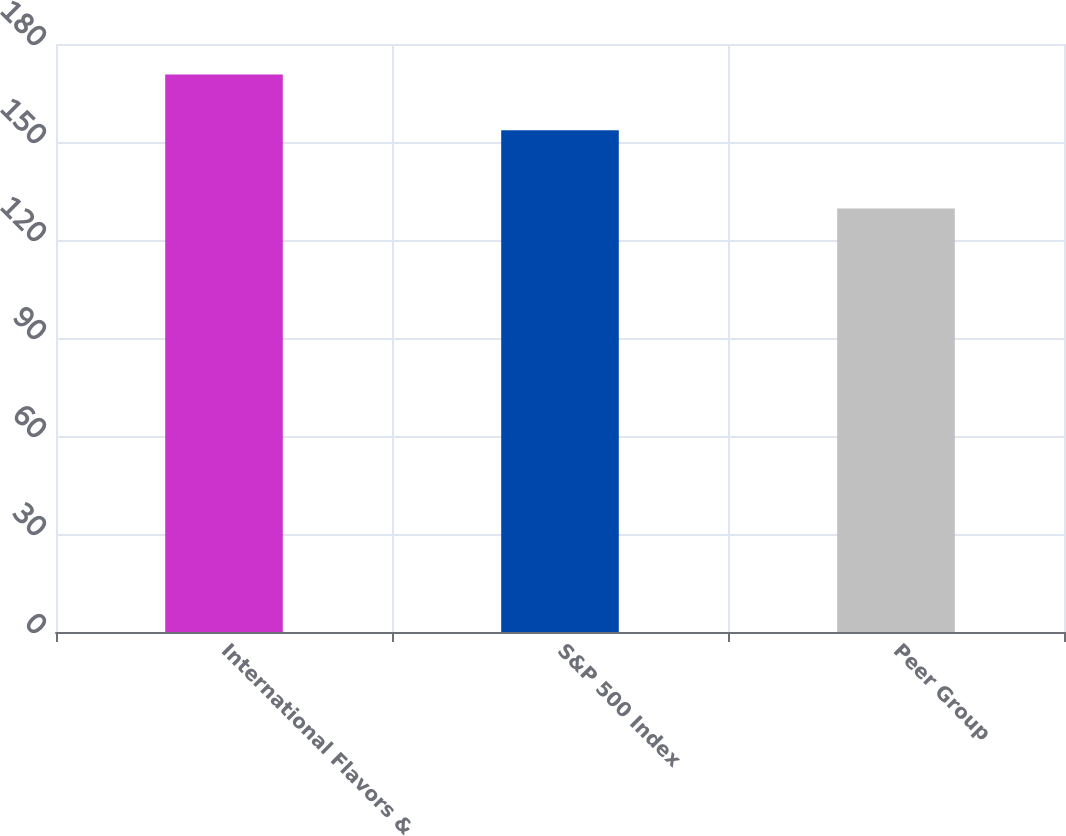Convert chart to OTSL. <chart><loc_0><loc_0><loc_500><loc_500><bar_chart><fcel>International Flavors &<fcel>S&P 500 Index<fcel>Peer Group<nl><fcel>170.7<fcel>153.57<fcel>129.66<nl></chart> 